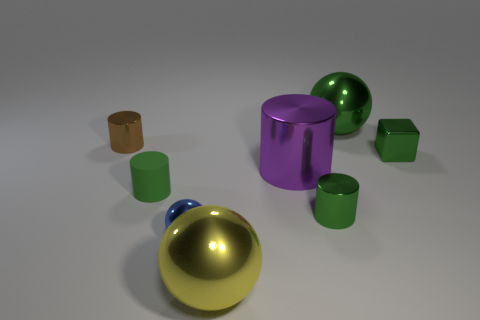The green cylinder that is made of the same material as the large yellow ball is what size? The green cylinder appears to be small in size in comparison to other objects in the image, notably smaller than the large yellow ball with which it shares a shiny, reflective surface indicating they are made from a similar material. 